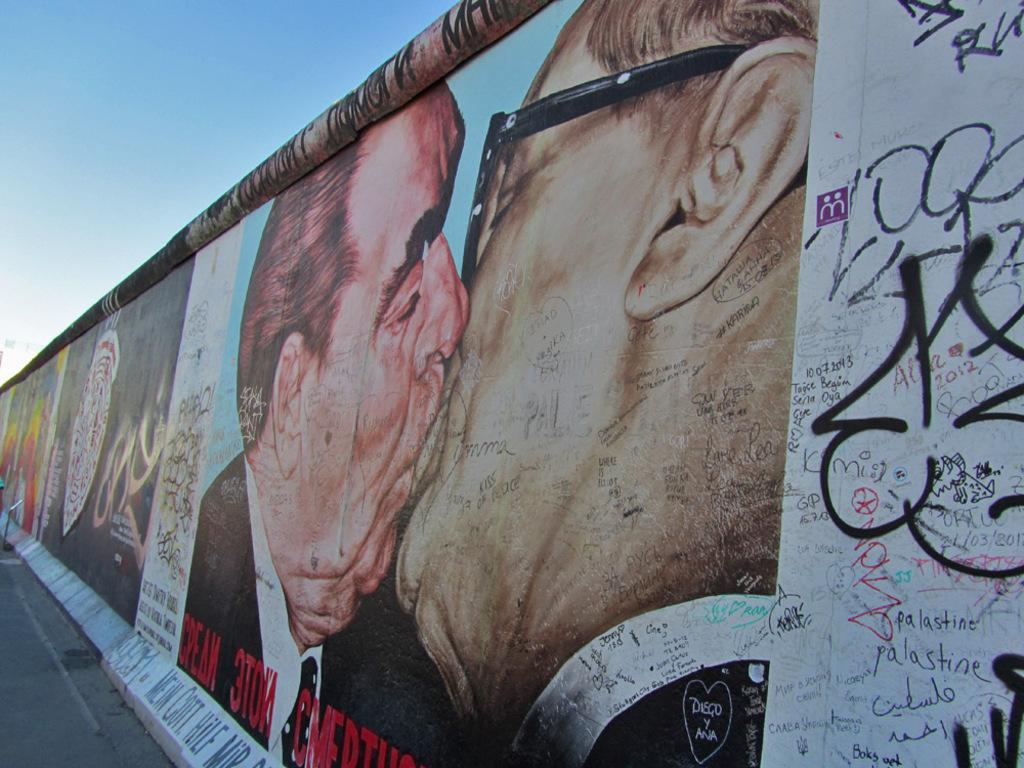What is present on the wall in the image? There are posters and graffiti on the wall in the image. How many people can be seen in the image? There are two persons in the image. What is visible at the top of the image? The sky is visible at the top of the image. Can you see any matches being used by the persons in the image? There is no mention of matches or their use in the image. How many babies are present in the image? There is no mention of babies in the image. 